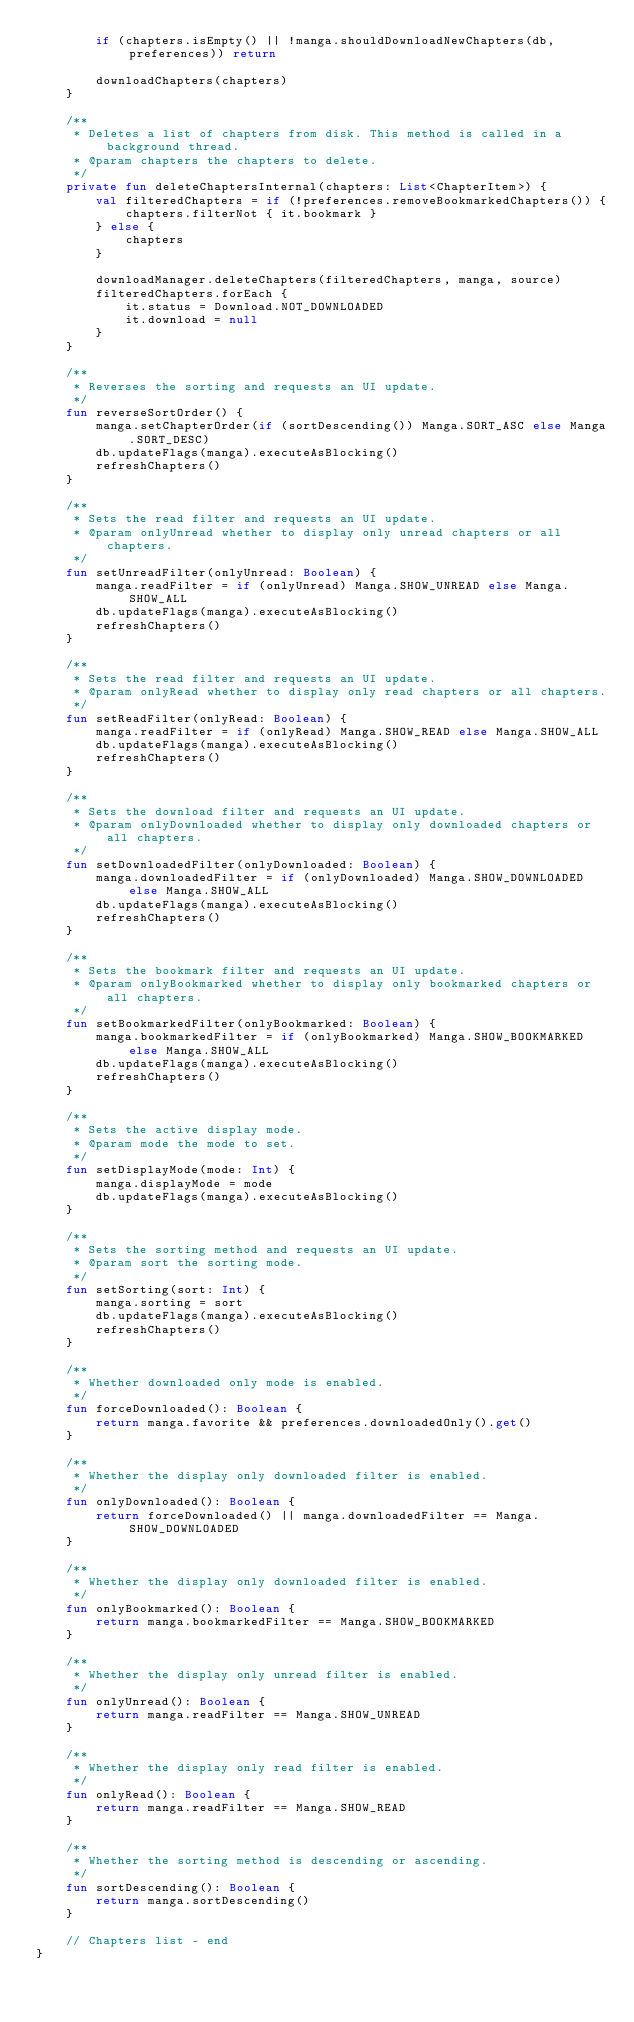Convert code to text. <code><loc_0><loc_0><loc_500><loc_500><_Kotlin_>        if (chapters.isEmpty() || !manga.shouldDownloadNewChapters(db, preferences)) return

        downloadChapters(chapters)
    }

    /**
     * Deletes a list of chapters from disk. This method is called in a background thread.
     * @param chapters the chapters to delete.
     */
    private fun deleteChaptersInternal(chapters: List<ChapterItem>) {
        val filteredChapters = if (!preferences.removeBookmarkedChapters()) {
            chapters.filterNot { it.bookmark }
        } else {
            chapters
        }

        downloadManager.deleteChapters(filteredChapters, manga, source)
        filteredChapters.forEach {
            it.status = Download.NOT_DOWNLOADED
            it.download = null
        }
    }

    /**
     * Reverses the sorting and requests an UI update.
     */
    fun reverseSortOrder() {
        manga.setChapterOrder(if (sortDescending()) Manga.SORT_ASC else Manga.SORT_DESC)
        db.updateFlags(manga).executeAsBlocking()
        refreshChapters()
    }

    /**
     * Sets the read filter and requests an UI update.
     * @param onlyUnread whether to display only unread chapters or all chapters.
     */
    fun setUnreadFilter(onlyUnread: Boolean) {
        manga.readFilter = if (onlyUnread) Manga.SHOW_UNREAD else Manga.SHOW_ALL
        db.updateFlags(manga).executeAsBlocking()
        refreshChapters()
    }

    /**
     * Sets the read filter and requests an UI update.
     * @param onlyRead whether to display only read chapters or all chapters.
     */
    fun setReadFilter(onlyRead: Boolean) {
        manga.readFilter = if (onlyRead) Manga.SHOW_READ else Manga.SHOW_ALL
        db.updateFlags(manga).executeAsBlocking()
        refreshChapters()
    }

    /**
     * Sets the download filter and requests an UI update.
     * @param onlyDownloaded whether to display only downloaded chapters or all chapters.
     */
    fun setDownloadedFilter(onlyDownloaded: Boolean) {
        manga.downloadedFilter = if (onlyDownloaded) Manga.SHOW_DOWNLOADED else Manga.SHOW_ALL
        db.updateFlags(manga).executeAsBlocking()
        refreshChapters()
    }

    /**
     * Sets the bookmark filter and requests an UI update.
     * @param onlyBookmarked whether to display only bookmarked chapters or all chapters.
     */
    fun setBookmarkedFilter(onlyBookmarked: Boolean) {
        manga.bookmarkedFilter = if (onlyBookmarked) Manga.SHOW_BOOKMARKED else Manga.SHOW_ALL
        db.updateFlags(manga).executeAsBlocking()
        refreshChapters()
    }

    /**
     * Sets the active display mode.
     * @param mode the mode to set.
     */
    fun setDisplayMode(mode: Int) {
        manga.displayMode = mode
        db.updateFlags(manga).executeAsBlocking()
    }

    /**
     * Sets the sorting method and requests an UI update.
     * @param sort the sorting mode.
     */
    fun setSorting(sort: Int) {
        manga.sorting = sort
        db.updateFlags(manga).executeAsBlocking()
        refreshChapters()
    }

    /**
     * Whether downloaded only mode is enabled.
     */
    fun forceDownloaded(): Boolean {
        return manga.favorite && preferences.downloadedOnly().get()
    }

    /**
     * Whether the display only downloaded filter is enabled.
     */
    fun onlyDownloaded(): Boolean {
        return forceDownloaded() || manga.downloadedFilter == Manga.SHOW_DOWNLOADED
    }

    /**
     * Whether the display only downloaded filter is enabled.
     */
    fun onlyBookmarked(): Boolean {
        return manga.bookmarkedFilter == Manga.SHOW_BOOKMARKED
    }

    /**
     * Whether the display only unread filter is enabled.
     */
    fun onlyUnread(): Boolean {
        return manga.readFilter == Manga.SHOW_UNREAD
    }

    /**
     * Whether the display only read filter is enabled.
     */
    fun onlyRead(): Boolean {
        return manga.readFilter == Manga.SHOW_READ
    }

    /**
     * Whether the sorting method is descending or ascending.
     */
    fun sortDescending(): Boolean {
        return manga.sortDescending()
    }

    // Chapters list - end
}
</code> 